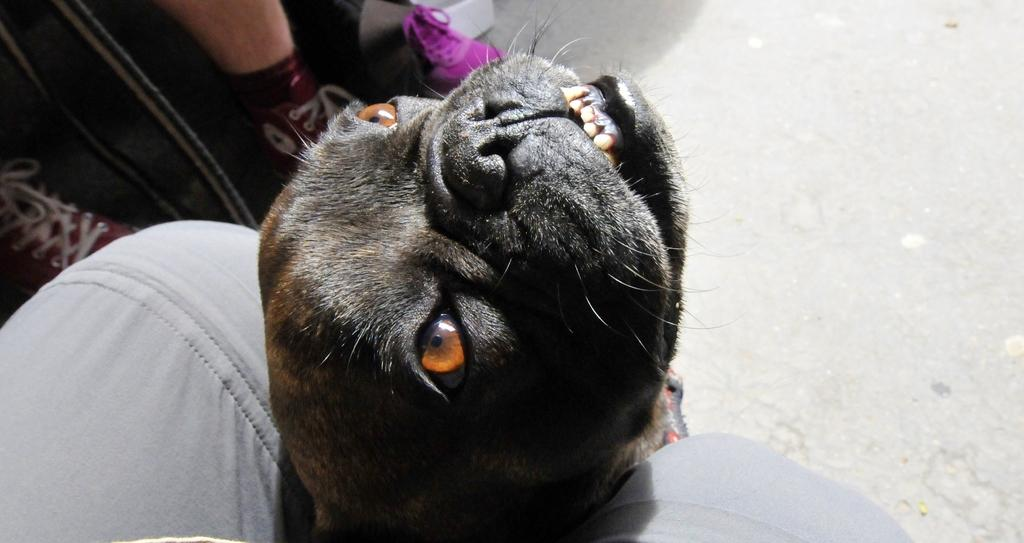What animal is present in the image? There is a dog in the image. Where is the dog located in relation to the people? The dog is between the legs of a person. How many people are visible in the image? There are two people visible in the image. What part of the second person is visible in the image? The legs of the second person are visible in the image. What is the purpose of the cattle in the image? There are no cattle present in the image. On which channel can the image be found? The image is not associated with a specific channel, as it is a static image and not a video or broadcast. 